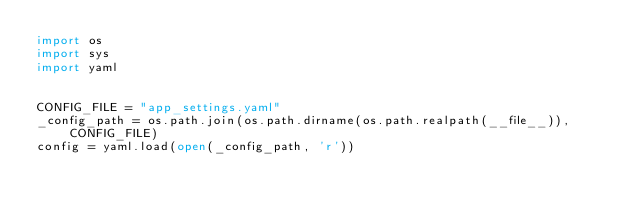<code> <loc_0><loc_0><loc_500><loc_500><_Python_>import os
import sys
import yaml


CONFIG_FILE = "app_settings.yaml"
_config_path = os.path.join(os.path.dirname(os.path.realpath(__file__)), CONFIG_FILE)
config = yaml.load(open(_config_path, 'r'))
</code> 